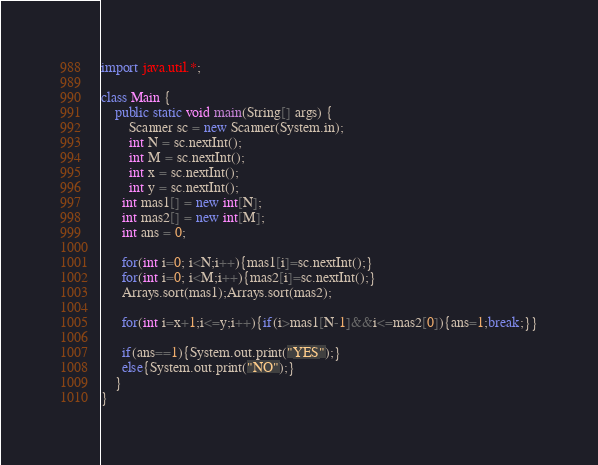<code> <loc_0><loc_0><loc_500><loc_500><_Java_>import java.util.*;

class Main {
    public static void main(String[] args) {
        Scanner sc = new Scanner(System.in);
        int N = sc.nextInt();
        int M = sc.nextInt();
        int x = sc.nextInt();
      	int y = sc.nextInt();
      int mas1[] = new int[N]; 
      int mas2[] = new int[M];
      int ans = 0;
      
      for(int i=0; i<N;i++){mas1[i]=sc.nextInt();}
      for(int i=0; i<M;i++){mas2[i]=sc.nextInt();}
      Arrays.sort(mas1);Arrays.sort(mas2);
      
      for(int i=x+1;i<=y;i++){if(i>mas1[N-1]&&i<=mas2[0]){ans=1;break;}}
      
      if(ans==1){System.out.print("YES");}
      else{System.out.print("NO");}
	}
}</code> 